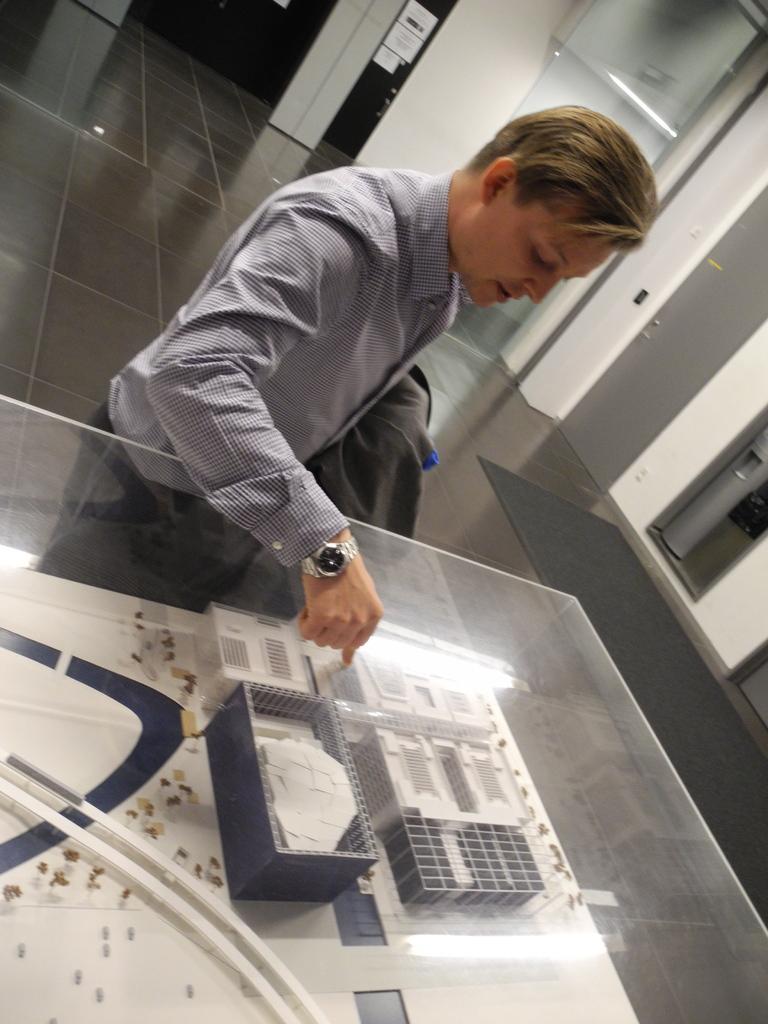In one or two sentences, can you explain what this image depicts? In this picture we can see a man is standing, there is a glass at the bottom, from the glass we can see boxes, in the background there is a wall, on the right side there is a door, we can see some papers past in the background. 